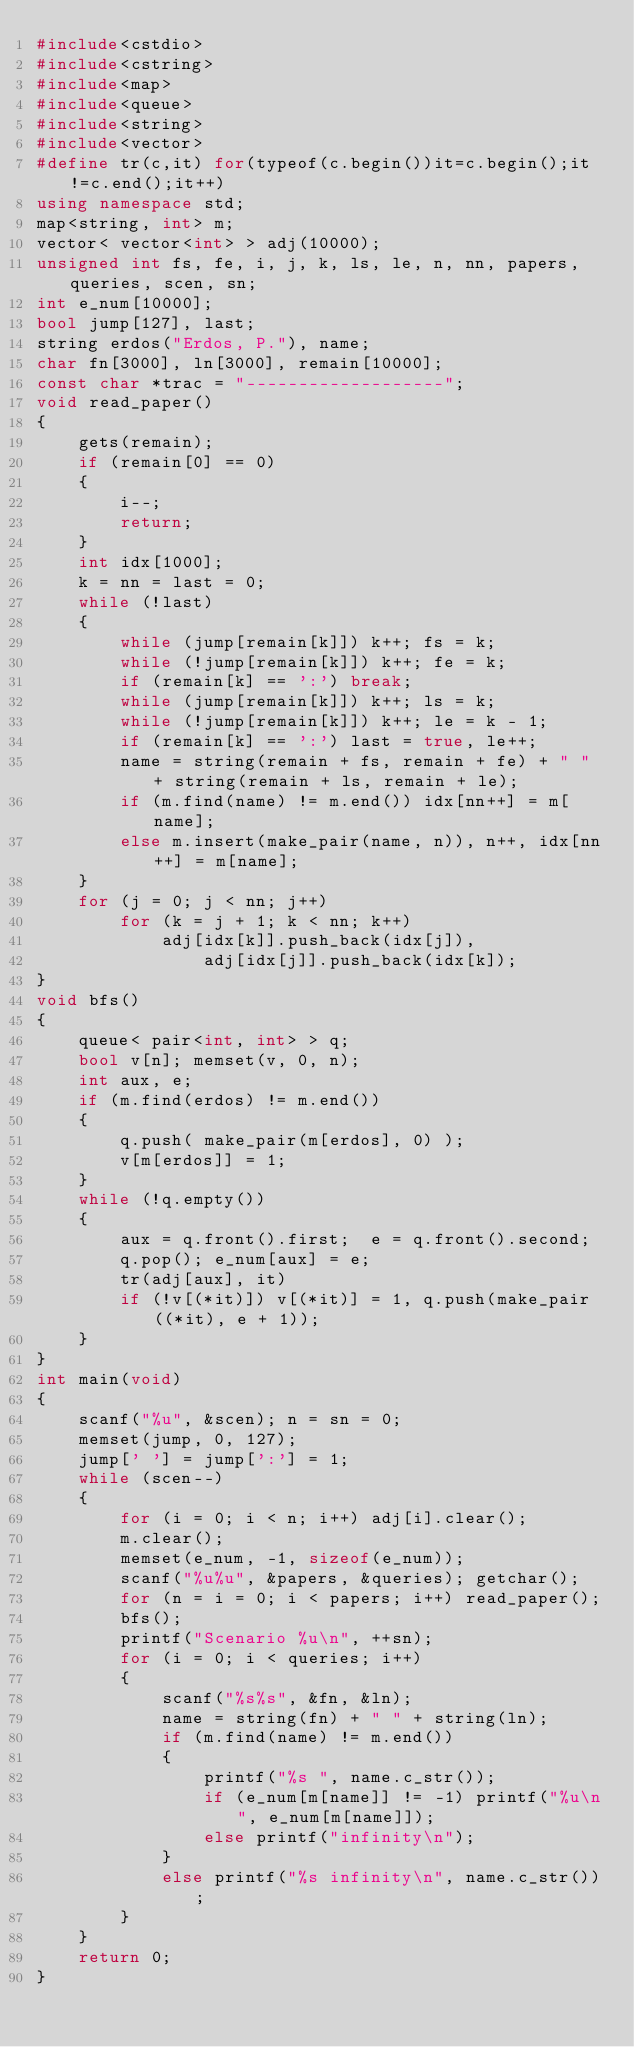<code> <loc_0><loc_0><loc_500><loc_500><_C++_>#include<cstdio>
#include<cstring>
#include<map>
#include<queue>
#include<string>
#include<vector>
#define tr(c,it) for(typeof(c.begin())it=c.begin();it!=c.end();it++)
using namespace std;
map<string, int> m;
vector< vector<int> > adj(10000);
unsigned int fs, fe, i, j, k, ls, le, n, nn, papers, queries, scen, sn;
int e_num[10000];
bool jump[127], last;
string erdos("Erdos, P."), name;
char fn[3000], ln[3000], remain[10000];
const char *trac = "-------------------";
void read_paper()
{
    gets(remain);
    if (remain[0] == 0)
    {
        i--;
        return;
    }
    int idx[1000];
    k = nn = last = 0;
    while (!last)
    {
        while (jump[remain[k]]) k++; fs = k;
        while (!jump[remain[k]]) k++; fe = k;
        if (remain[k] == ':') break;
        while (jump[remain[k]]) k++; ls = k;
        while (!jump[remain[k]]) k++; le = k - 1;
        if (remain[k] == ':') last = true, le++;
        name = string(remain + fs, remain + fe) + " " + string(remain + ls, remain + le);
        if (m.find(name) != m.end()) idx[nn++] = m[name];
        else m.insert(make_pair(name, n)), n++, idx[nn++] = m[name];
    }
    for (j = 0; j < nn; j++)
        for (k = j + 1; k < nn; k++)
            adj[idx[k]].push_back(idx[j]),
                adj[idx[j]].push_back(idx[k]);
}
void bfs()
{
    queue< pair<int, int> > q;
    bool v[n]; memset(v, 0, n);
    int aux, e;
    if (m.find(erdos) != m.end())
    {
        q.push( make_pair(m[erdos], 0) );
        v[m[erdos]] = 1;
    }
    while (!q.empty())
    {
        aux = q.front().first;  e = q.front().second;
        q.pop(); e_num[aux] = e;
        tr(adj[aux], it)
        if (!v[(*it)]) v[(*it)] = 1, q.push(make_pair((*it), e + 1));
    }
}
int main(void)
{
    scanf("%u", &scen); n = sn = 0;
    memset(jump, 0, 127);
    jump[' '] = jump[':'] = 1;
    while (scen--)
    {
        for (i = 0; i < n; i++) adj[i].clear();
        m.clear();
        memset(e_num, -1, sizeof(e_num));
        scanf("%u%u", &papers, &queries); getchar();
        for (n = i = 0; i < papers; i++) read_paper();
        bfs();
        printf("Scenario %u\n", ++sn);
        for (i = 0; i < queries; i++)
        {
            scanf("%s%s", &fn, &ln);
            name = string(fn) + " " + string(ln);
            if (m.find(name) != m.end())
            {
                printf("%s ", name.c_str());
                if (e_num[m[name]] != -1) printf("%u\n", e_num[m[name]]);
                else printf("infinity\n");
            }
            else printf("%s infinity\n", name.c_str());
        }
    }
    return 0;
}
</code> 